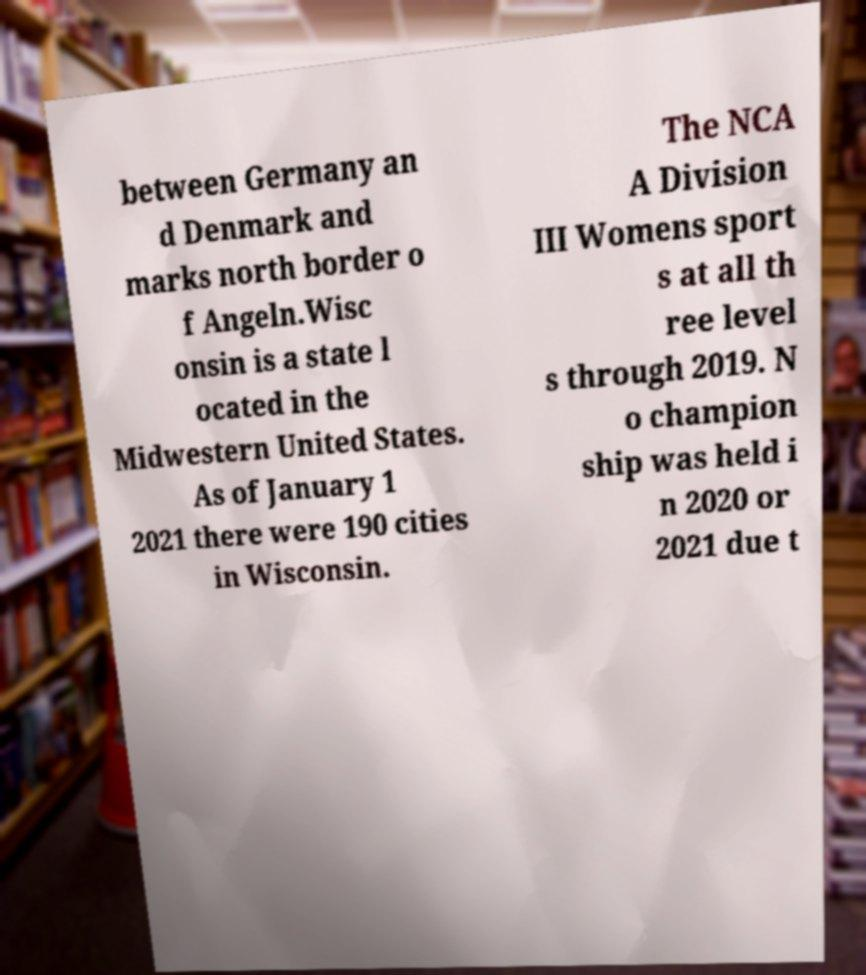Please read and relay the text visible in this image. What does it say? between Germany an d Denmark and marks north border o f Angeln.Wisc onsin is a state l ocated in the Midwestern United States. As of January 1 2021 there were 190 cities in Wisconsin. The NCA A Division III Womens sport s at all th ree level s through 2019. N o champion ship was held i n 2020 or 2021 due t 